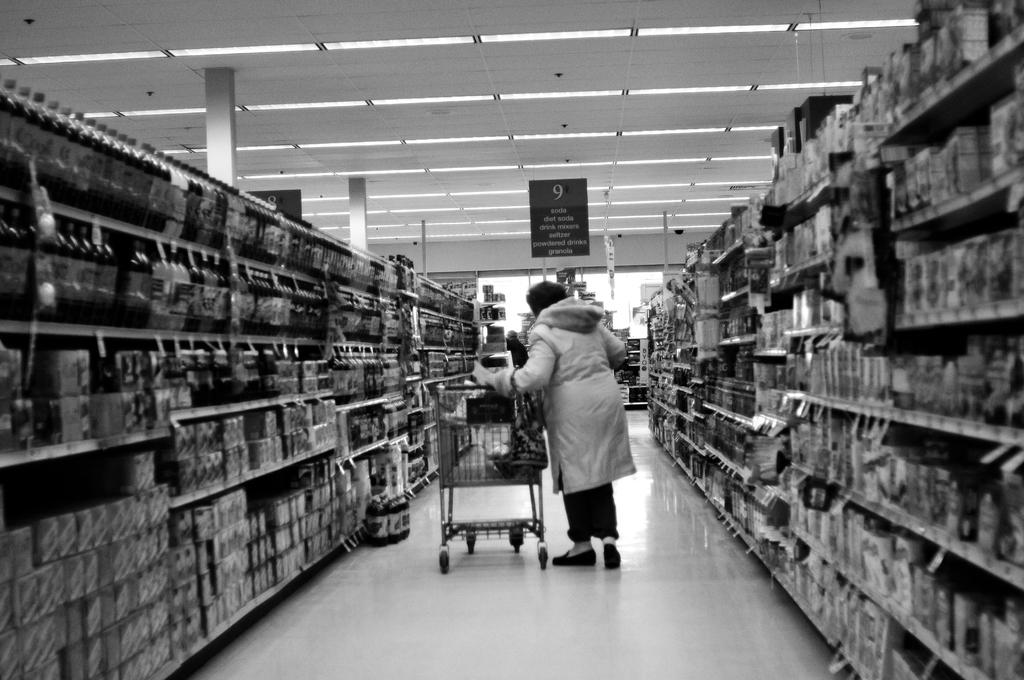<image>
Summarize the visual content of the image. woman in heavy coat going down isle 9 of grocery store where she can find soda, drink mixers, powdered drinks, and granola 